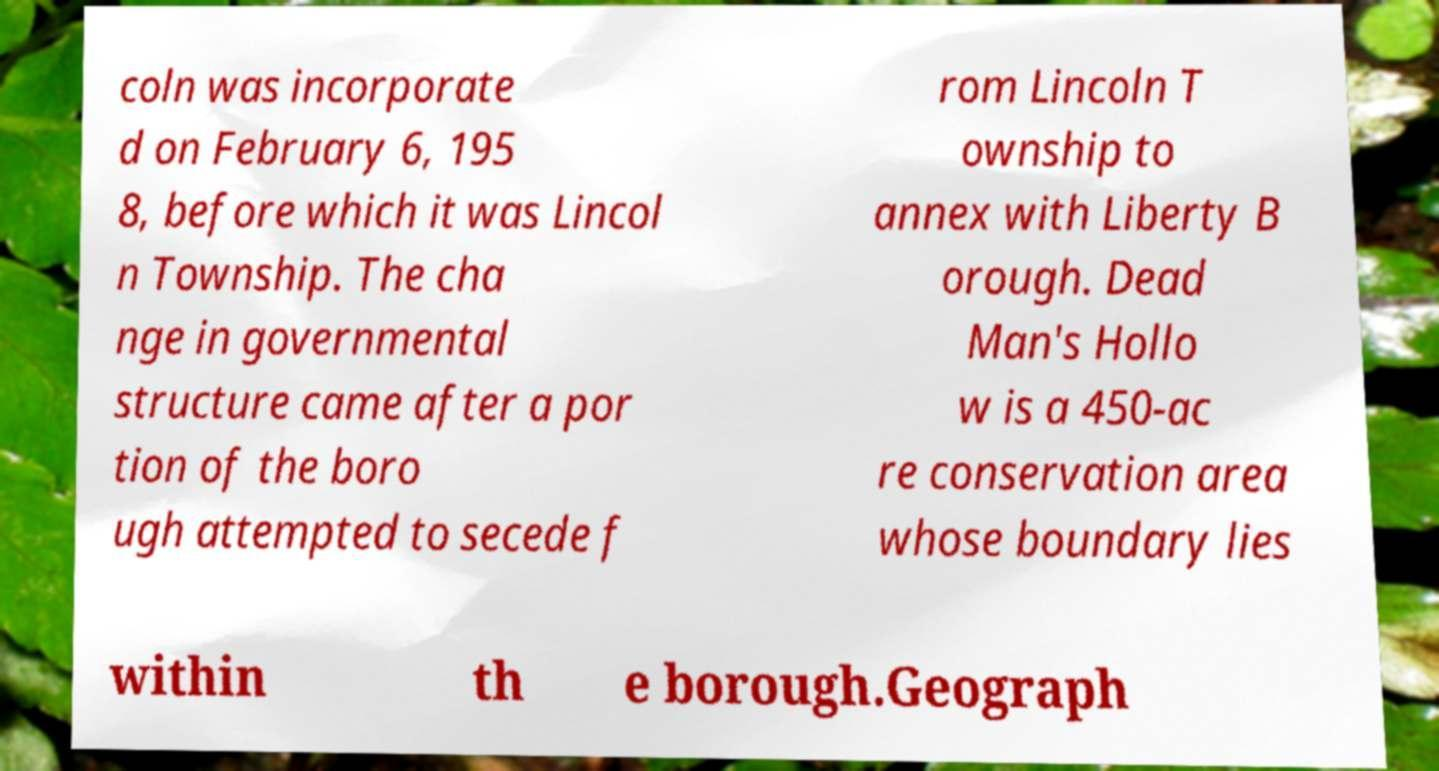Could you extract and type out the text from this image? coln was incorporate d on February 6, 195 8, before which it was Lincol n Township. The cha nge in governmental structure came after a por tion of the boro ugh attempted to secede f rom Lincoln T ownship to annex with Liberty B orough. Dead Man's Hollo w is a 450-ac re conservation area whose boundary lies within th e borough.Geograph 